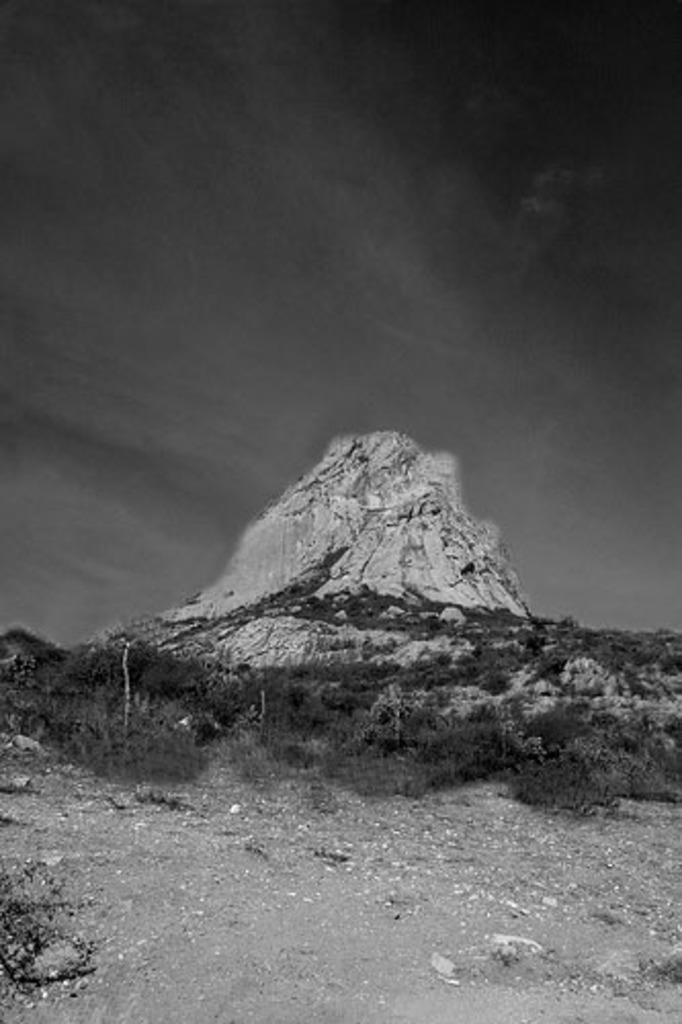Please provide a concise description of this image. This is a black and white pic. At the bottom we can see grass and trees on the ground. In the background we can a mountain and clouds in the sky. 